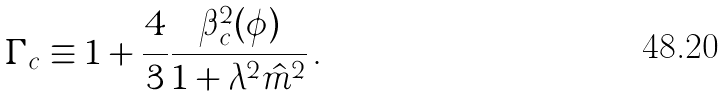<formula> <loc_0><loc_0><loc_500><loc_500>\Gamma _ { c } \equiv 1 + \frac { 4 } { 3 } \frac { \beta _ { c } ^ { 2 } ( \phi ) } { 1 + \lambda ^ { 2 } \hat { m } ^ { 2 } } \, .</formula> 